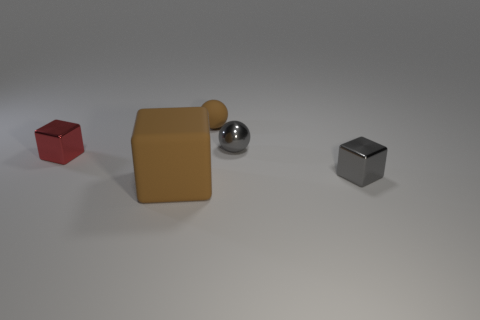Subtract all tiny cubes. How many cubes are left? 1 Add 3 brown cubes. How many objects exist? 8 Subtract all cubes. How many objects are left? 2 Subtract all spheres. Subtract all metal things. How many objects are left? 0 Add 5 brown spheres. How many brown spheres are left? 6 Add 3 small gray things. How many small gray things exist? 5 Subtract 0 green cubes. How many objects are left? 5 